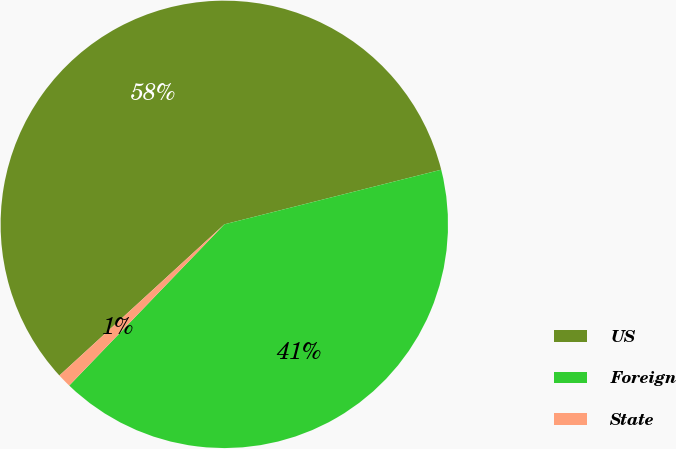Convert chart to OTSL. <chart><loc_0><loc_0><loc_500><loc_500><pie_chart><fcel>US<fcel>Foreign<fcel>State<nl><fcel>57.88%<fcel>41.12%<fcel>1.0%<nl></chart> 